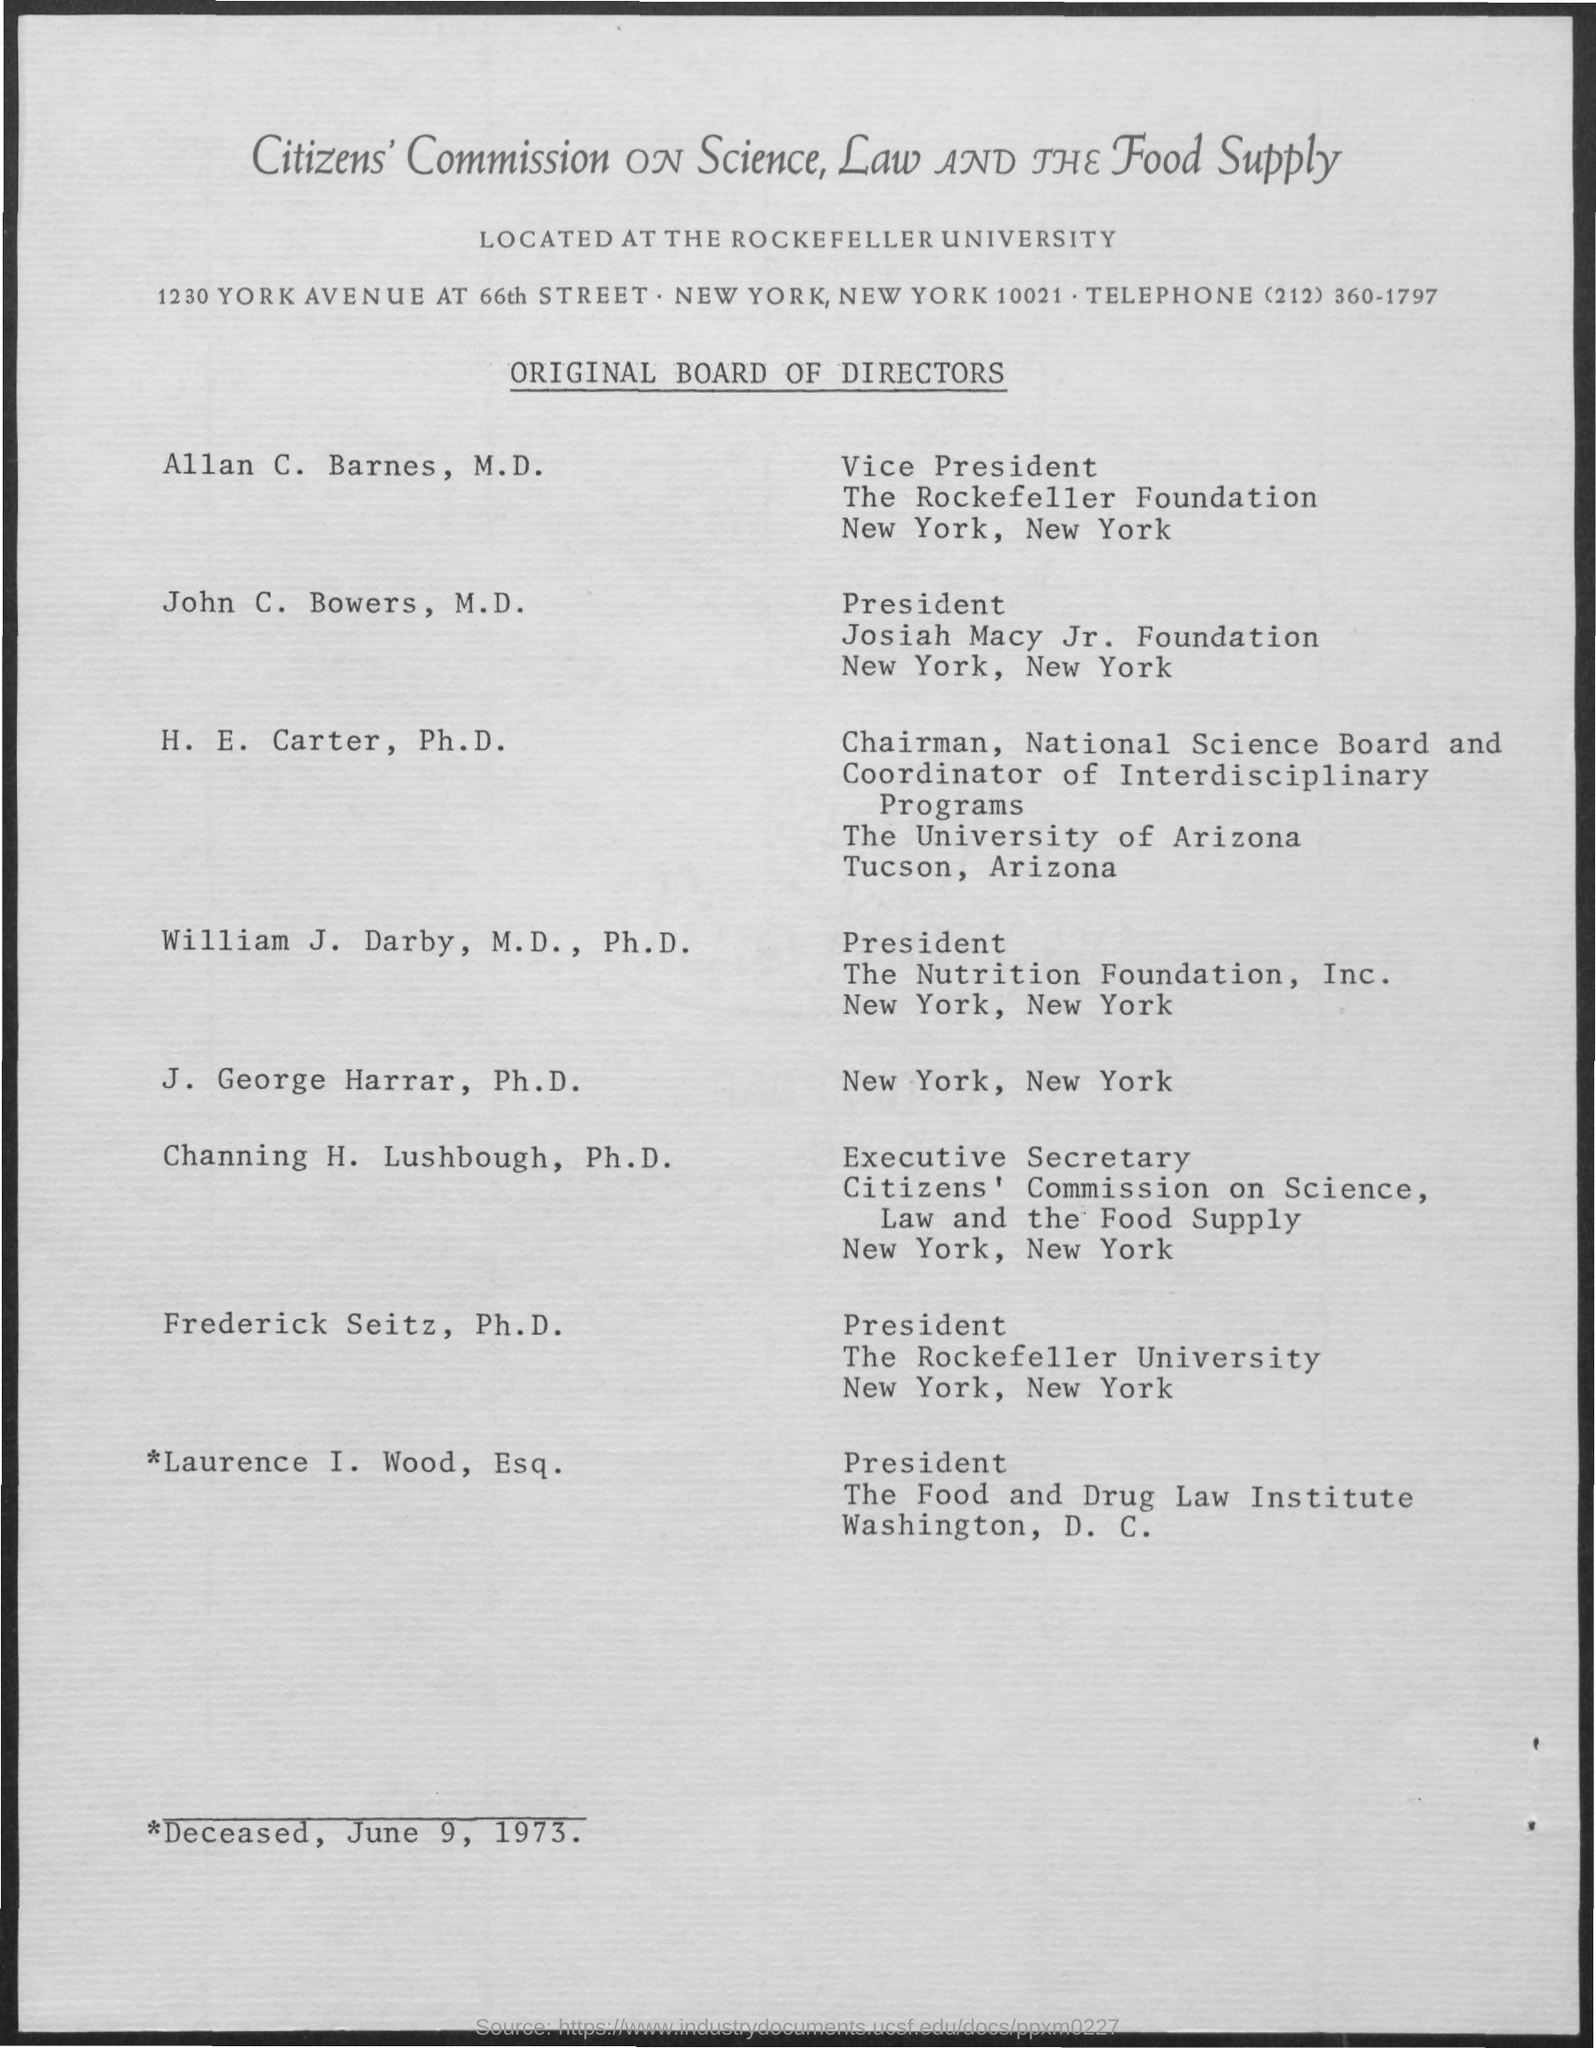Draw attention to some important aspects in this diagram. I, Allan C. Barnes, am the Vice President of the Rockefeller Foundation. The telephone number mentioned in the given page is (212) 360-1797. 